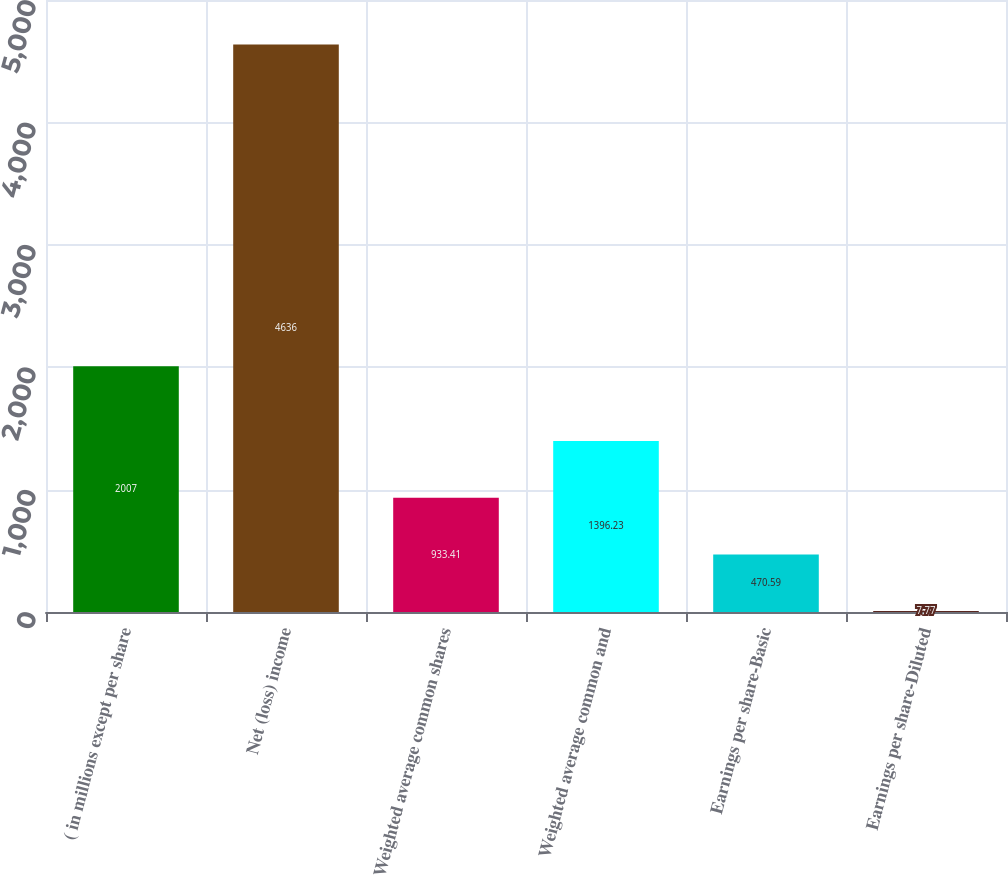<chart> <loc_0><loc_0><loc_500><loc_500><bar_chart><fcel>( in millions except per share<fcel>Net (loss) income<fcel>Weighted average common shares<fcel>Weighted average common and<fcel>Earnings per share-Basic<fcel>Earnings per share-Diluted<nl><fcel>2007<fcel>4636<fcel>933.41<fcel>1396.23<fcel>470.59<fcel>7.77<nl></chart> 